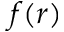<formula> <loc_0><loc_0><loc_500><loc_500>f ( r )</formula> 